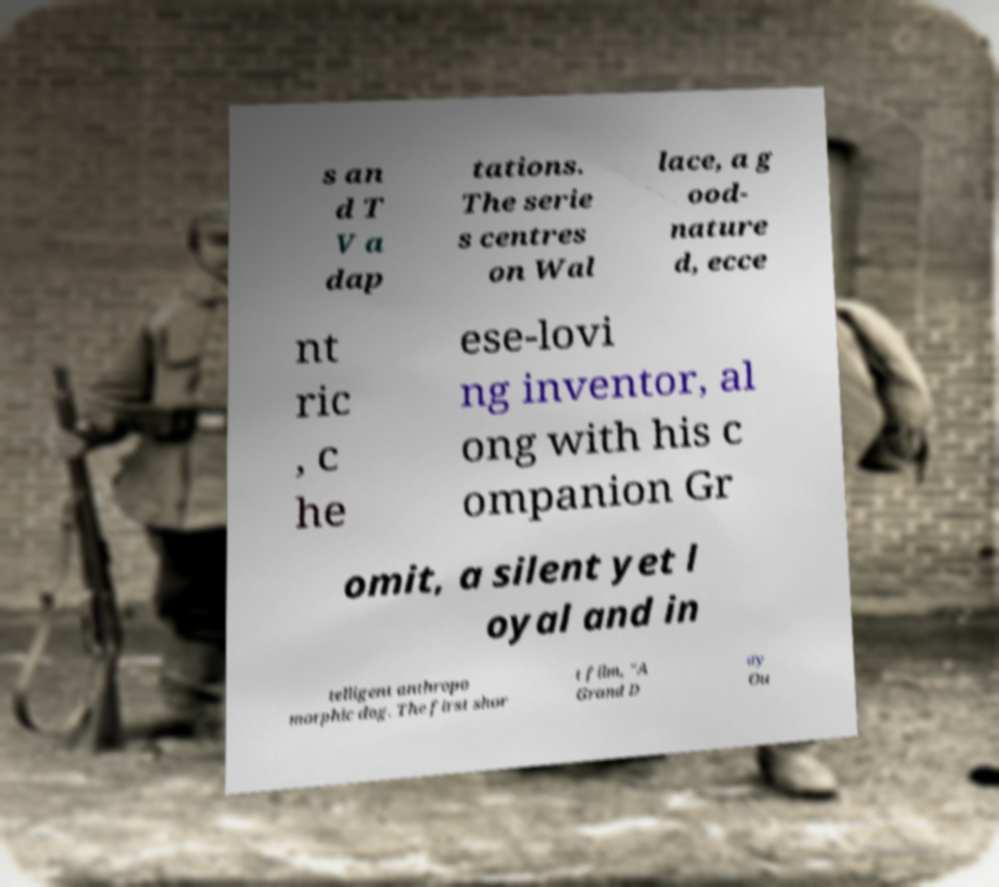Please identify and transcribe the text found in this image. s an d T V a dap tations. The serie s centres on Wal lace, a g ood- nature d, ecce nt ric , c he ese-lovi ng inventor, al ong with his c ompanion Gr omit, a silent yet l oyal and in telligent anthropo morphic dog. The first shor t film, "A Grand D ay Ou 